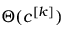<formula> <loc_0><loc_0><loc_500><loc_500>\Theta ( c ^ { [ k ] } )</formula> 